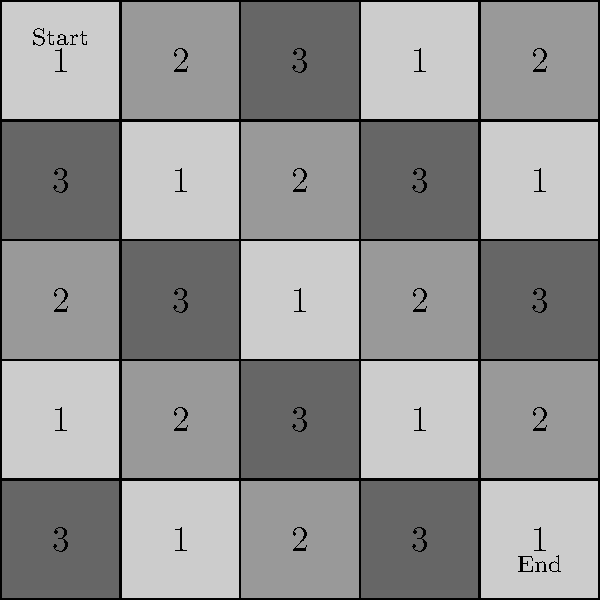In this 5x5 grid representing a maze-like terrain, each cell contains a number indicating the movement cost. You start at the top-left corner and aim to reach the bottom-right corner. What is the minimum total cost to traverse the maze, considering that you can only move right or down? To solve this problem, we'll use dynamic programming to find the most efficient path:

1) Create a 5x5 grid to store the minimum cost to reach each cell.

2) Initialize the top-left cell with its cost (1).

3) For the first row and column, calculate cumulative costs:
   - First row: 1, 3, 6, 7, 9
   - First column: 1, 4, 6, 7, 10

4) For each remaining cell (i,j), calculate:
   $$\text{minCost}(i,j) = \min(\text{minCost}(i-1,j), \text{minCost}(i,j-1)) + \text{cost}(i,j)$$

5) Fill the grid row by row:

   $$\begin{bmatrix}
   1 & 3 & 6 & 7 & 9 \\
   4 & 4 & 6 & 9 & 8 \\
   6 & 7 & 5 & 7 & 10 \\
   7 & 8 & 8 & 6 & 8 \\
   10 & 9 & 10 & 9 & 9
   \end{bmatrix}$$

6) The bottom-right cell contains the minimum total cost: 9.

The most efficient path is: (0,0) → (1,0) → (1,1) → (2,1) → (2,2) → (3,2) → (3,3) → (4,3) → (4,4)
Answer: 9 